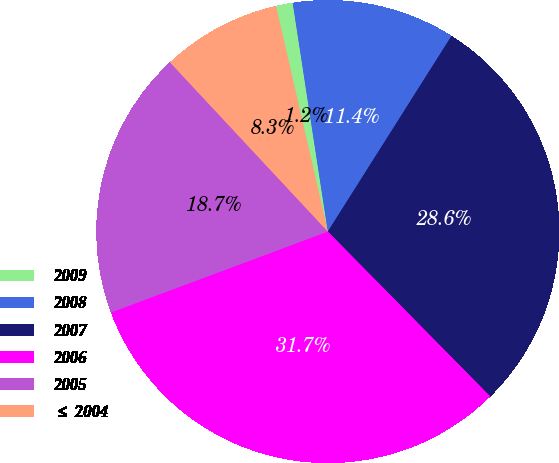Convert chart. <chart><loc_0><loc_0><loc_500><loc_500><pie_chart><fcel>2009<fcel>2008<fcel>2007<fcel>2006<fcel>2005<fcel>≤ 2004<nl><fcel>1.17%<fcel>11.4%<fcel>28.65%<fcel>31.7%<fcel>18.74%<fcel>8.35%<nl></chart> 